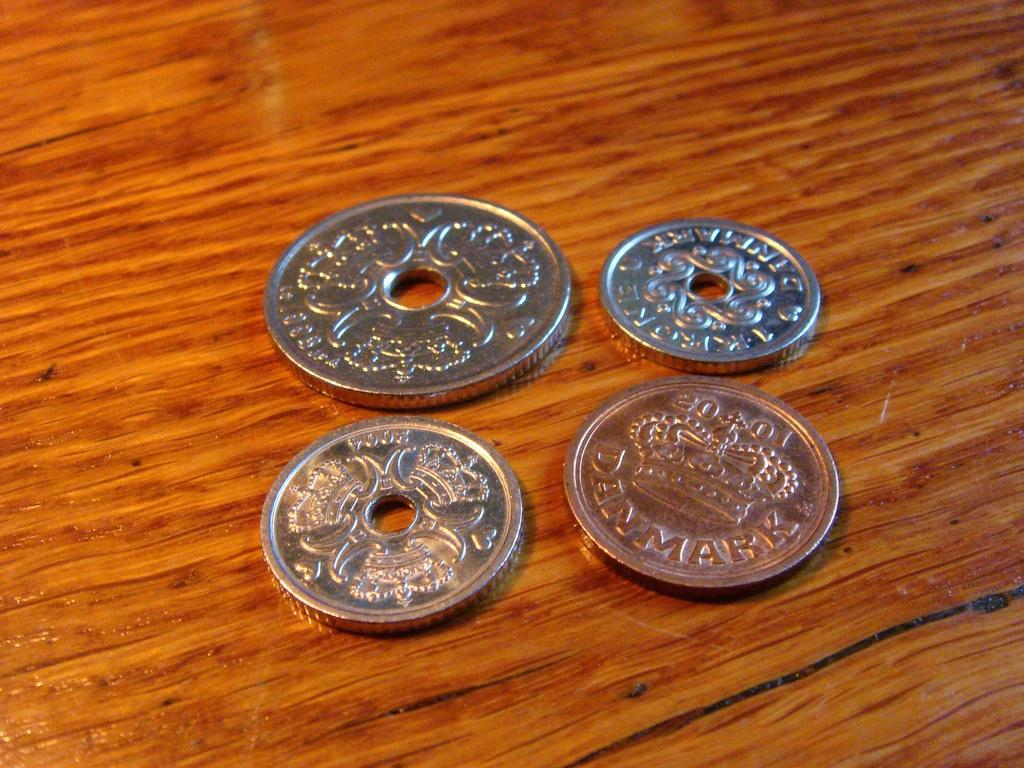<image>
Summarize the visual content of the image. four coins, at least one from Denmart, are laying on a table 